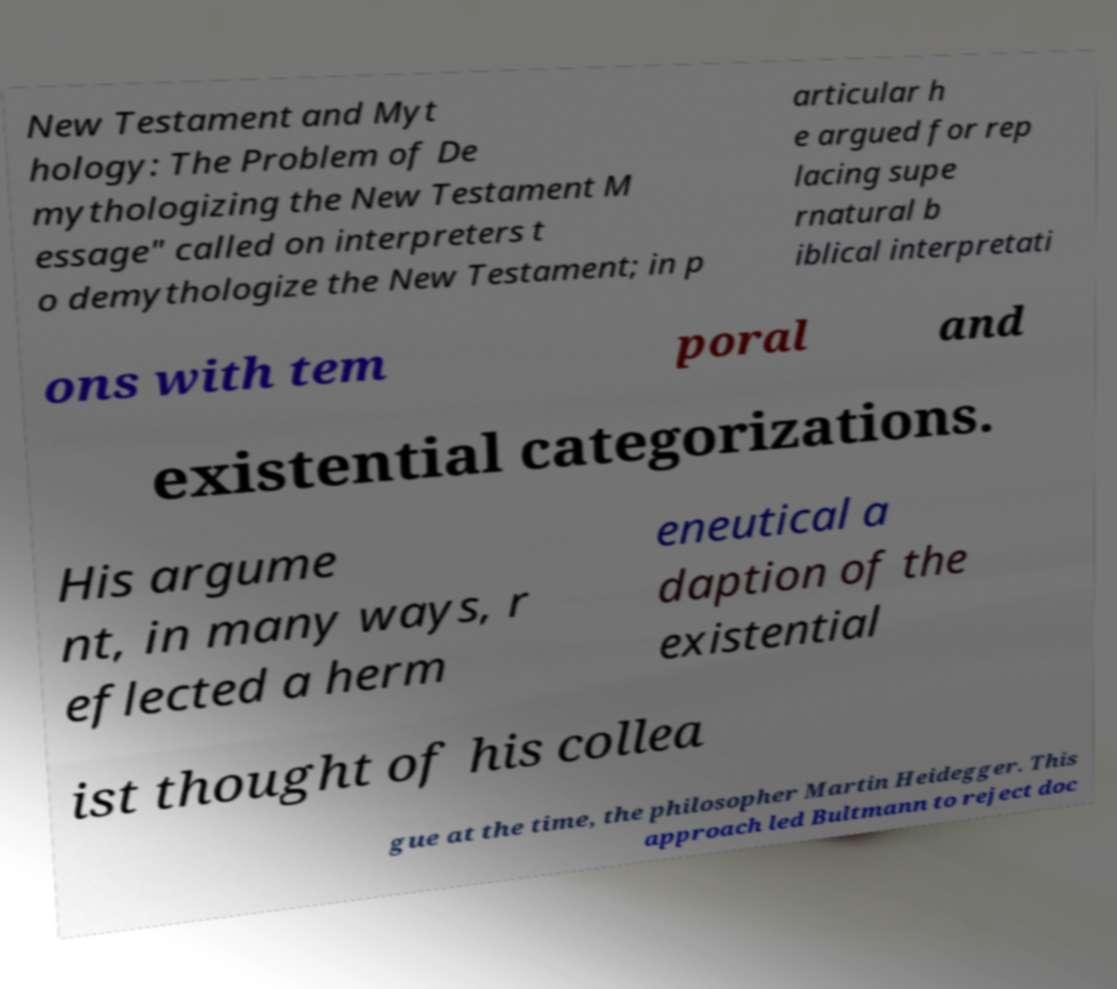For documentation purposes, I need the text within this image transcribed. Could you provide that? New Testament and Myt hology: The Problem of De mythologizing the New Testament M essage" called on interpreters t o demythologize the New Testament; in p articular h e argued for rep lacing supe rnatural b iblical interpretati ons with tem poral and existential categorizations. His argume nt, in many ways, r eflected a herm eneutical a daption of the existential ist thought of his collea gue at the time, the philosopher Martin Heidegger. This approach led Bultmann to reject doc 